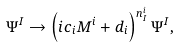Convert formula to latex. <formula><loc_0><loc_0><loc_500><loc_500>\Psi ^ { I } \rightarrow \left ( i c _ { i } M ^ { i } + d _ { i } \right ) ^ { n ^ { i } _ { I } } \Psi ^ { I } ,</formula> 